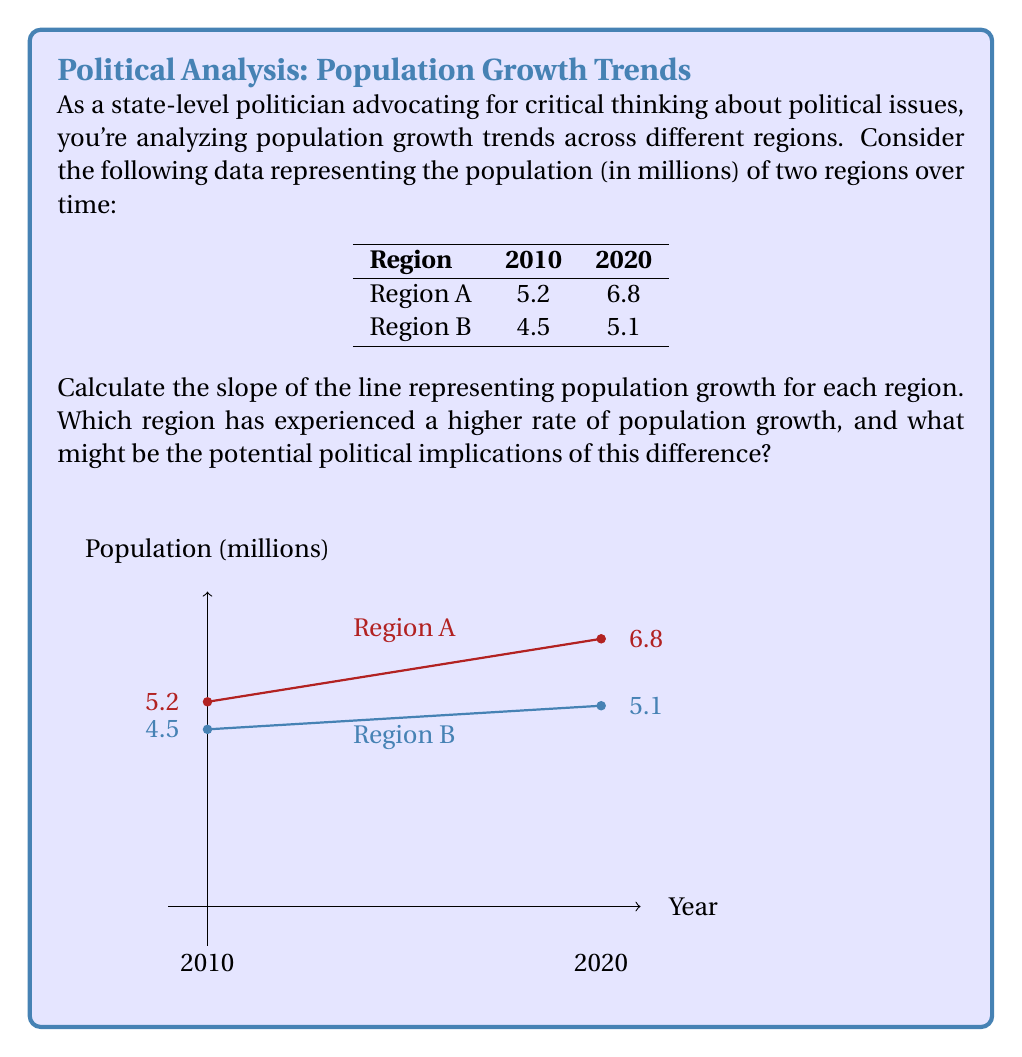Can you answer this question? To solve this problem, we need to calculate the slope for each region using the slope formula:

$$ m = \frac{y_2 - y_1}{x_2 - x_1} $$

Where $(x_1, y_1)$ is the first point and $(x_2, y_2)$ is the second point.

For Region A:
$x_1 = 2010$, $y_1 = 5.2$
$x_2 = 2020$, $y_2 = 6.8$

$$ m_A = \frac{6.8 - 5.2}{2020 - 2010} = \frac{1.6}{10} = 0.16 $$

For Region B:
$x_1 = 2010$, $y_1 = 4.5$
$x_2 = 2020$, $y_2 = 5.1$

$$ m_B = \frac{5.1 - 4.5}{2020 - 2010} = \frac{0.6}{10} = 0.06 $$

The slope represents the rate of population growth per year. Region A has a slope of 0.16, which means it grows by 0.16 million people per year. Region B has a slope of 0.06, growing by 0.06 million people per year.

Region A has experienced a higher rate of population growth (0.16 > 0.06).

Potential political implications:
1. Resource allocation: Region A may require more infrastructure and services.
2. Representation: Region A might demand more political representation.
3. Economic impact: Faster growth in Region A could lead to economic opportunities and challenges.
4. Environmental concerns: Rapid growth in Region A may raise environmental issues.
5. Social dynamics: Demographic changes could affect social policies and community needs.

These implications encourage critical thinking about how population growth trends influence various aspects of governance and policy-making.
Answer: Region A slope: 0.16, Region B slope: 0.06. Region A has higher growth rate. 